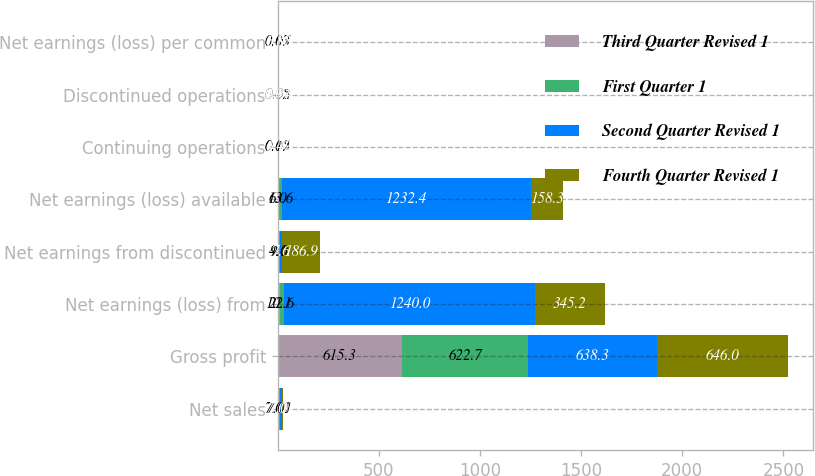Convert chart. <chart><loc_0><loc_0><loc_500><loc_500><stacked_bar_chart><ecel><fcel>Net sales<fcel>Gross profit<fcel>Net earnings (loss) from<fcel>Net earnings from discontinued<fcel>Net earnings (loss) available<fcel>Continuing operations<fcel>Discontinued operations<fcel>Net earnings (loss) per common<nl><fcel>Third Quarter Revised 1<fcel>7.01<fcel>615.3<fcel>10.1<fcel>4.1<fcel>6<fcel>0.05<fcel>0.02<fcel>0.03<nl><fcel>First Quarter 1<fcel>7.01<fcel>622.7<fcel>22.6<fcel>9<fcel>13.6<fcel>0.12<fcel>0.05<fcel>0.07<nl><fcel>Second Quarter Revised 1<fcel>7.01<fcel>638.3<fcel>1240<fcel>7.6<fcel>1232.4<fcel>6.42<fcel>0.04<fcel>6.38<nl><fcel>Fourth Quarter Revised 1<fcel>7.01<fcel>646<fcel>345.2<fcel>186.9<fcel>158.3<fcel>1.79<fcel>0.97<fcel>0.82<nl></chart> 